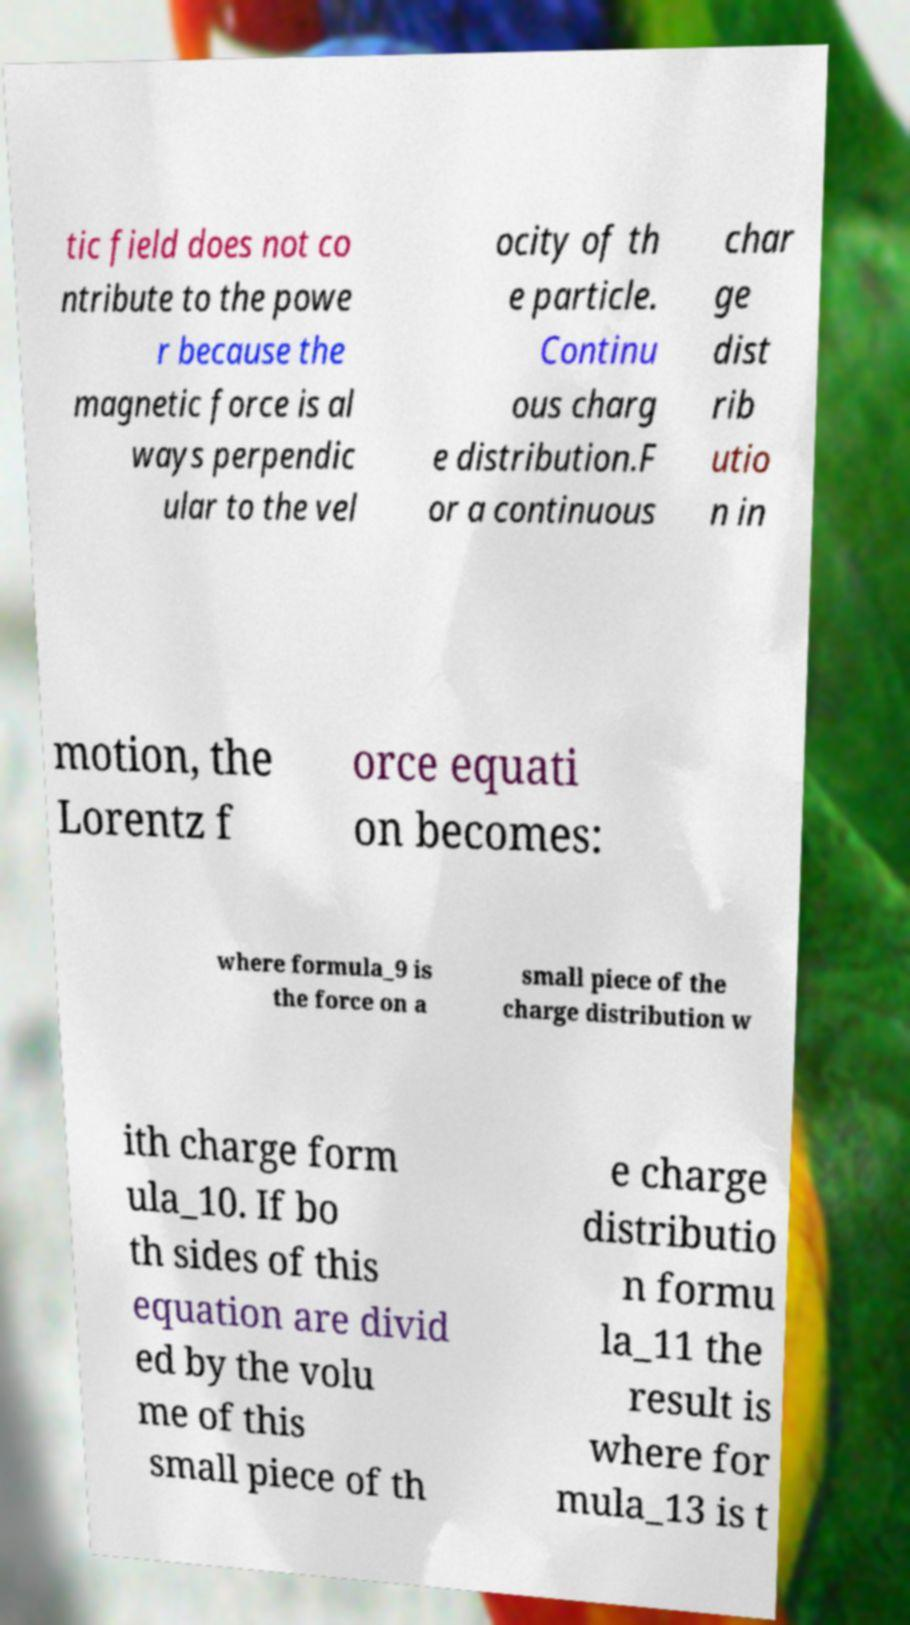Could you assist in decoding the text presented in this image and type it out clearly? tic field does not co ntribute to the powe r because the magnetic force is al ways perpendic ular to the vel ocity of th e particle. Continu ous charg e distribution.F or a continuous char ge dist rib utio n in motion, the Lorentz f orce equati on becomes: where formula_9 is the force on a small piece of the charge distribution w ith charge form ula_10. If bo th sides of this equation are divid ed by the volu me of this small piece of th e charge distributio n formu la_11 the result is where for mula_13 is t 